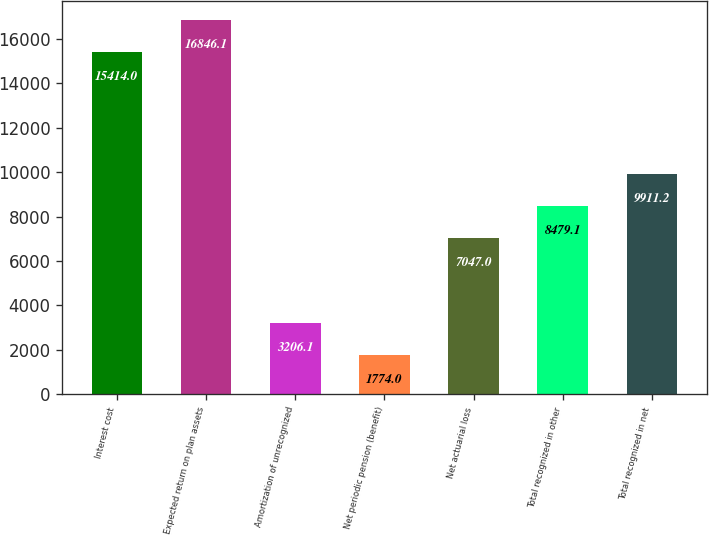Convert chart. <chart><loc_0><loc_0><loc_500><loc_500><bar_chart><fcel>Interest cost<fcel>Expected return on plan assets<fcel>Amortization of unrecognized<fcel>Net periodic pension (benefit)<fcel>Net actuarial loss<fcel>Total recognized in other<fcel>Total recognized in net<nl><fcel>15414<fcel>16846.1<fcel>3206.1<fcel>1774<fcel>7047<fcel>8479.1<fcel>9911.2<nl></chart> 